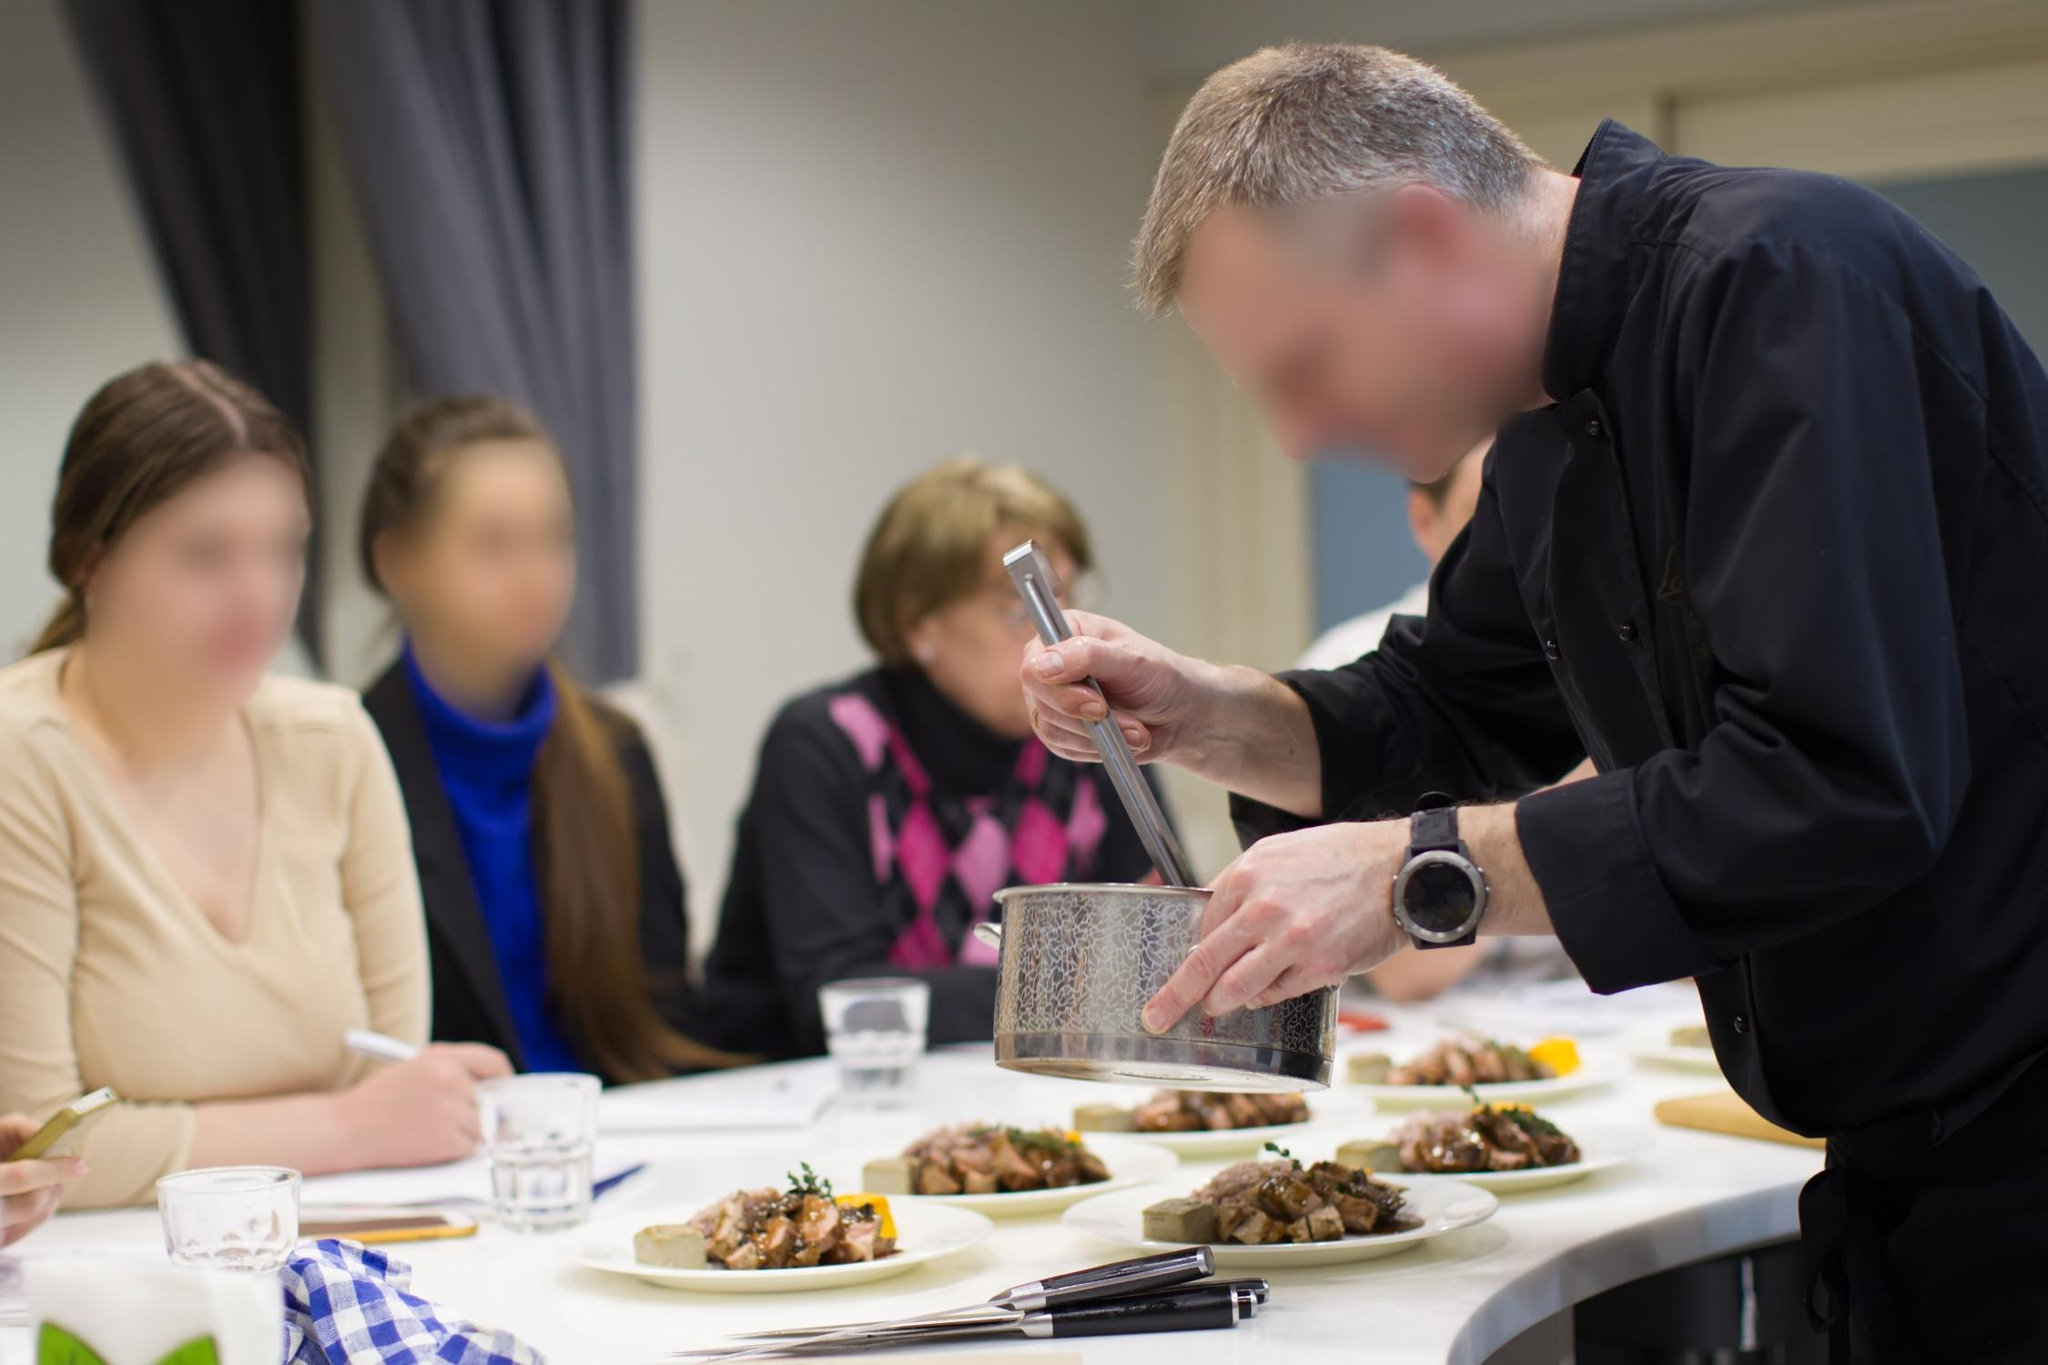Can you describe the main features of this image for me? The image depicts a vibrant cooking class scene in a brightly-lit kitchen. At the center, a chef dressed in a black chef's jacket is meticulously grating cheese over a gourmet dish placed on a plate. The chef uses a large silver grater, adding a final touch of artistry to his creation. The counter in front of him, covered with a blue and white checkered tablecloth, features three stylishly presented plates of food, highlighting the chef's culinary skills. Additionally, several cooking utensils are neatly placed on the counter, indicating a well-organized cooking area.

In the background, three focused spectators—a man and two women—are seated and watching the chef's demonstration attentively. Their blurred faces convey a sense of anonymity but their body language shows keen interest and engagement in the cooking process. This interaction between chef and audience adds a dynamic and communal atmosphere to the image, transforming the act of cooking into a shared, educational, and enjoyable experience. 